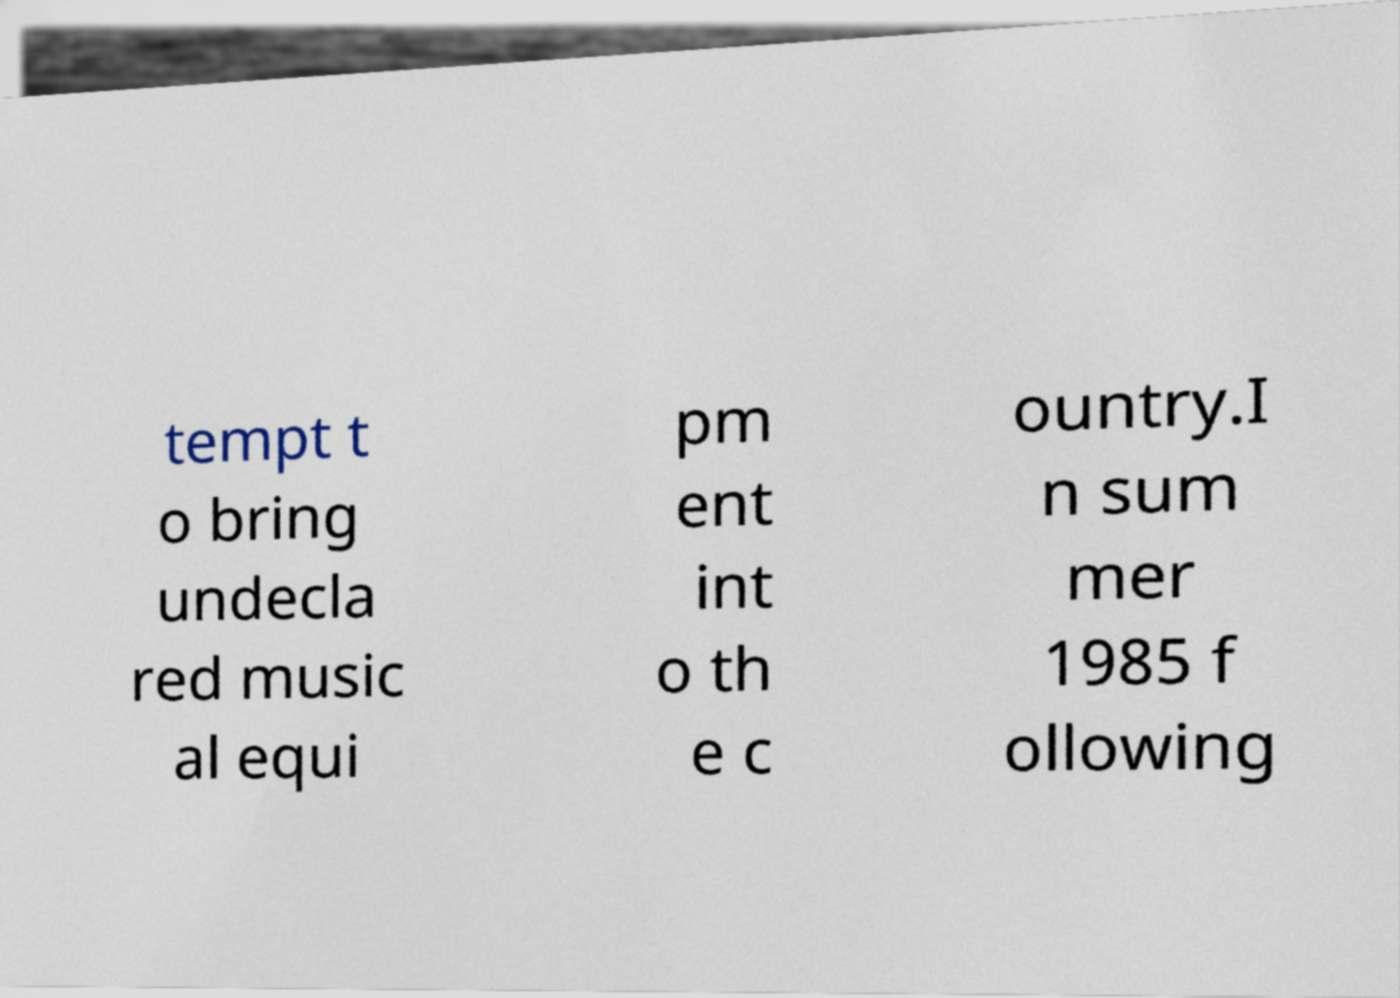Could you assist in decoding the text presented in this image and type it out clearly? tempt t o bring undecla red music al equi pm ent int o th e c ountry.I n sum mer 1985 f ollowing 